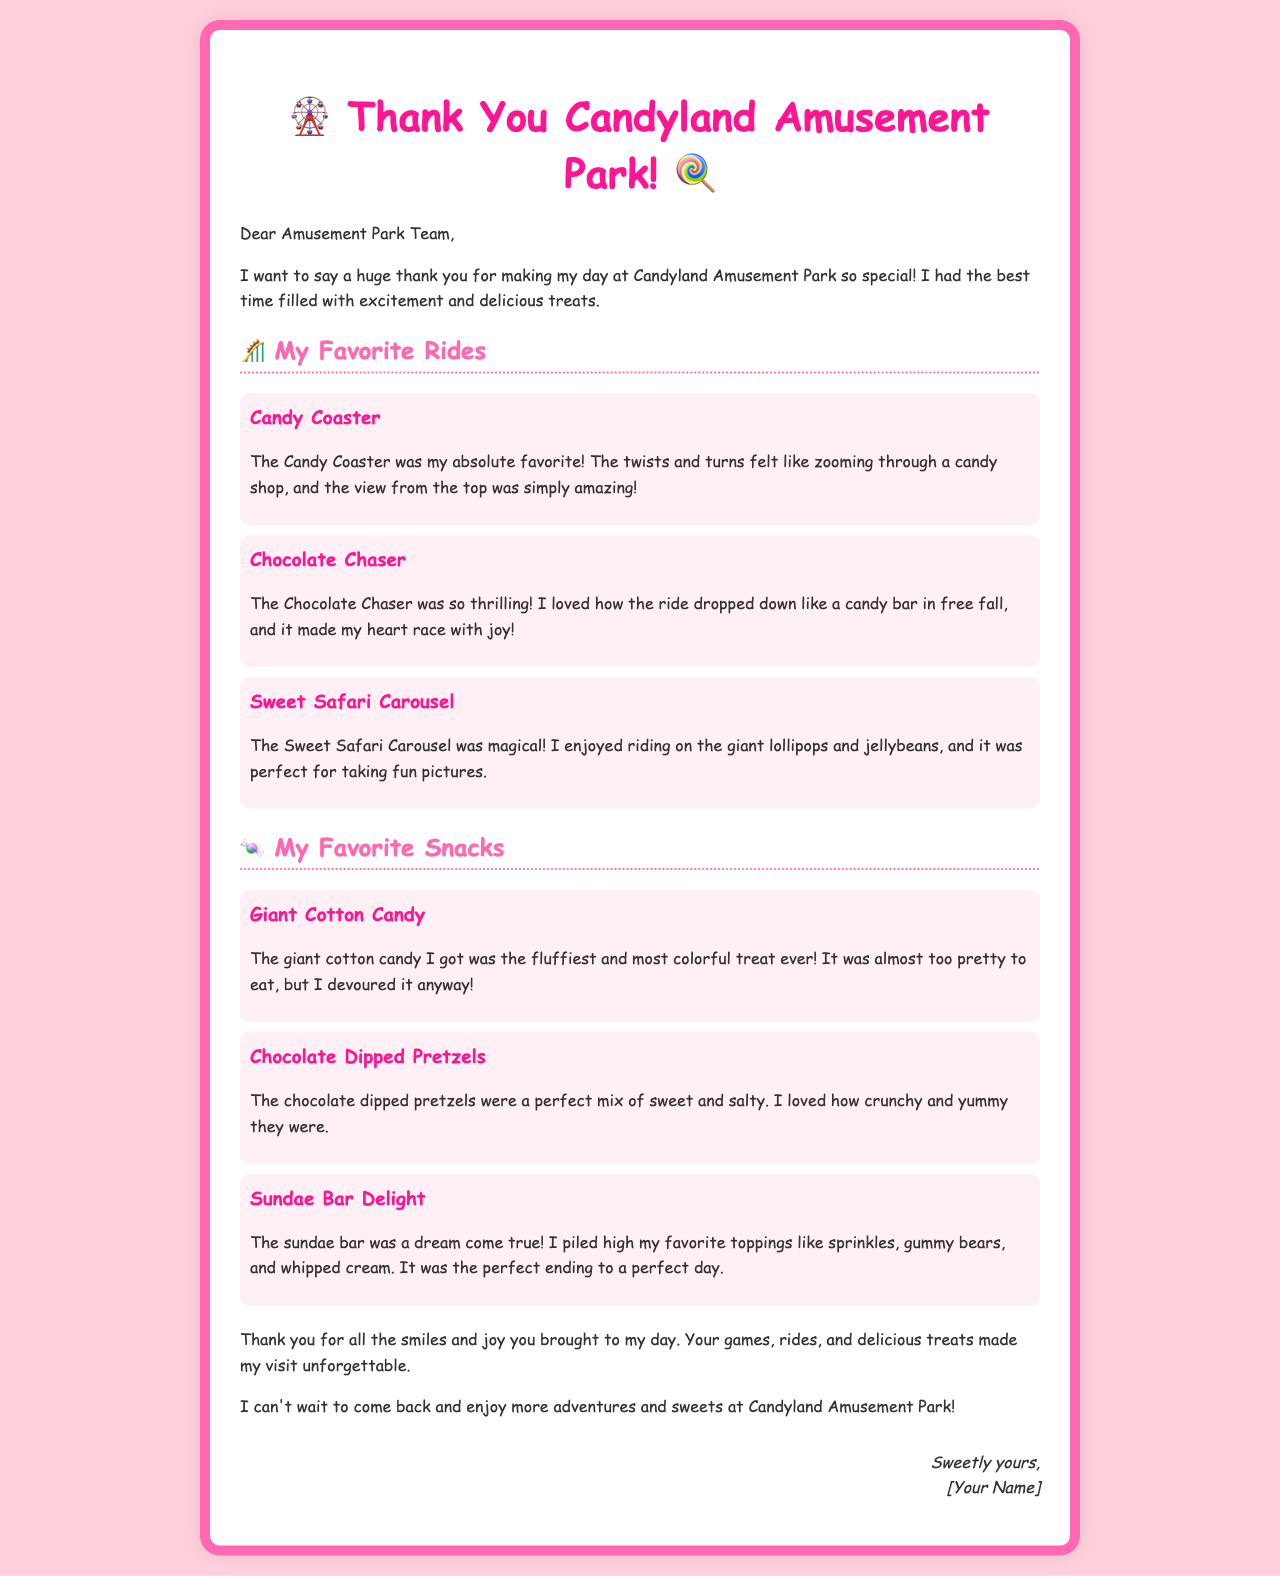What is the name of the amusement park? The name of the amusement park is Candyland Amusement Park, as mentioned in the letter's title.
Answer: Candyland Amusement Park Who is the letter addressed to? The letter is addressed to the Amusement Park Team, as stated in the salutation.
Answer: Amusement Park Team What was the favorite ride mentioned? The favorite ride mentioned is the Candy Coaster, which is highlighted in the section about rides.
Answer: Candy Coaster What snack was described as fluffy and colorful? The snack described as fluffy and colorful is the giant cotton candy, which is discussed in the snacks section.
Answer: Giant Cotton Candy How many rides are listed in the letter? There are three rides listed in the letter, each detailed in its own paragraph.
Answer: Three What toppings did the author pile on their sundae? The toppings mentioned for the sundae include sprinkles, gummy bears, and whipped cream, which are highlighted in the snack description.
Answer: Sprinkles, gummy bears, and whipped cream What kind of ride is the Sweet Safari Carousel? The Sweet Safari Carousel is described as magical, which indicates its charm and appeal in the letter.
Answer: Magical What emotion does the author express about their day at the amusement park? The author expresses joy and happiness about their day, as evident from their sentiment throughout the letter.
Answer: Joy How does the letter conclude? The letter concludes with an eager note from the author about looking forward to returning to the amusement park, as stated in the final paragraph.
Answer: Eager to return 